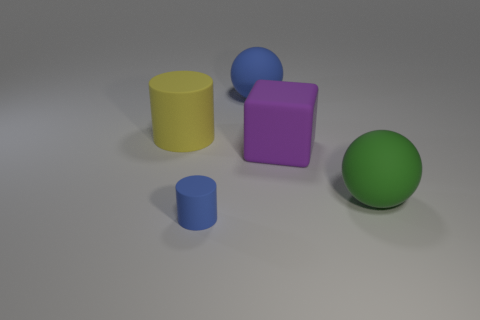Can you tell me which objects are closest to the front edge of the surface? The objects closest to the front edge are the small blue cylinder and the yellow rubber cylinder. They appear to be positioned in front of the other objects, giving them prominence in the image. 